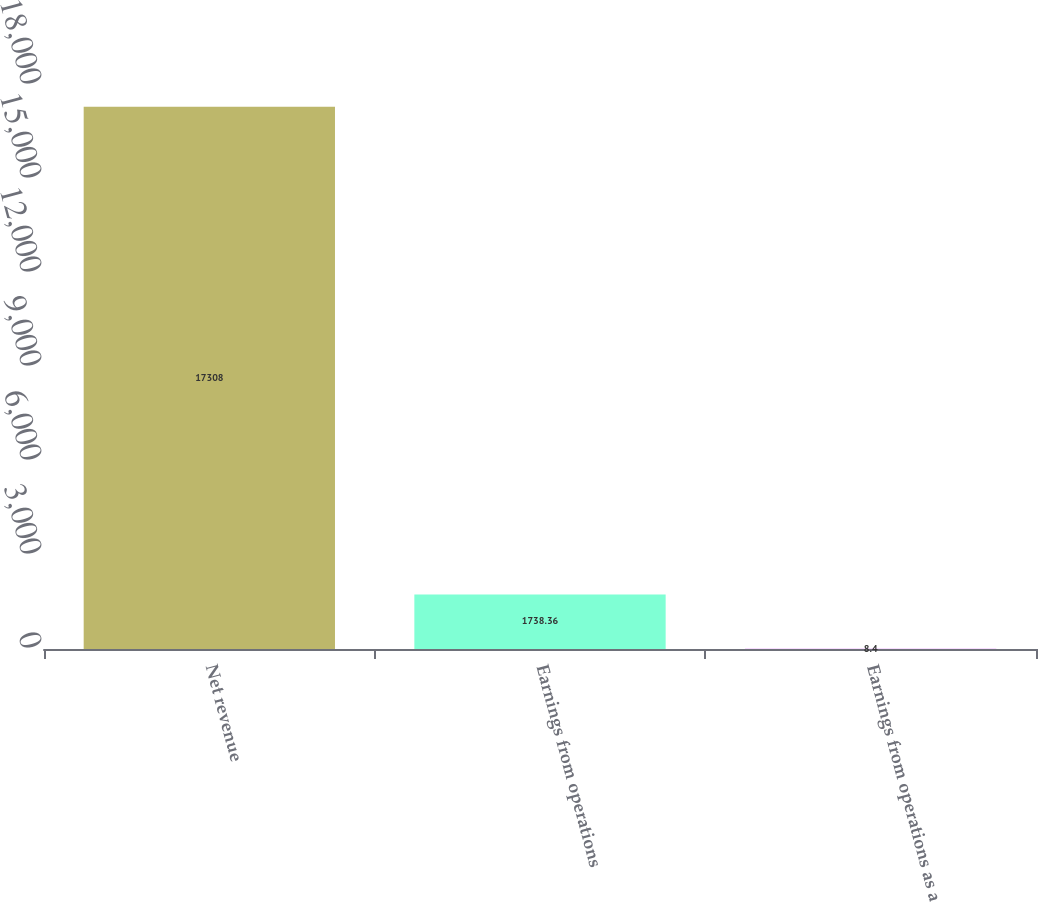<chart> <loc_0><loc_0><loc_500><loc_500><bar_chart><fcel>Net revenue<fcel>Earnings from operations<fcel>Earnings from operations as a<nl><fcel>17308<fcel>1738.36<fcel>8.4<nl></chart> 